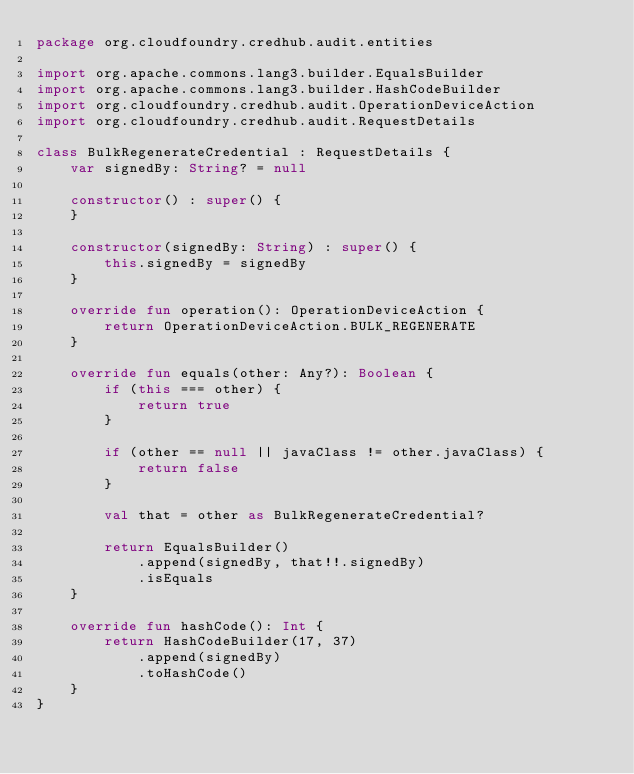Convert code to text. <code><loc_0><loc_0><loc_500><loc_500><_Kotlin_>package org.cloudfoundry.credhub.audit.entities

import org.apache.commons.lang3.builder.EqualsBuilder
import org.apache.commons.lang3.builder.HashCodeBuilder
import org.cloudfoundry.credhub.audit.OperationDeviceAction
import org.cloudfoundry.credhub.audit.RequestDetails

class BulkRegenerateCredential : RequestDetails {
    var signedBy: String? = null

    constructor() : super() {
    }

    constructor(signedBy: String) : super() {
        this.signedBy = signedBy
    }

    override fun operation(): OperationDeviceAction {
        return OperationDeviceAction.BULK_REGENERATE
    }

    override fun equals(other: Any?): Boolean {
        if (this === other) {
            return true
        }

        if (other == null || javaClass != other.javaClass) {
            return false
        }

        val that = other as BulkRegenerateCredential?

        return EqualsBuilder()
            .append(signedBy, that!!.signedBy)
            .isEquals
    }

    override fun hashCode(): Int {
        return HashCodeBuilder(17, 37)
            .append(signedBy)
            .toHashCode()
    }
}
</code> 